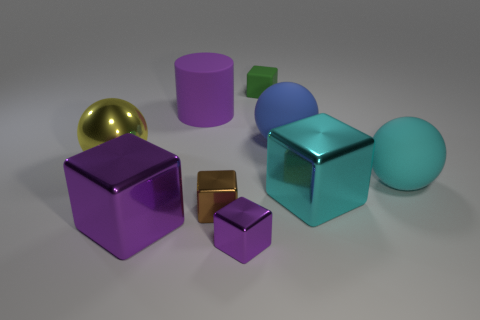Is the size of the metallic cube that is to the right of the tiny purple metal block the same as the rubber sphere in front of the blue rubber object? Upon closer examination of the image, it appears that the metallic cube to the right of the tiny purple metal block is indeed comparable in size to the rubber sphere situated in front of the blue rubber object. Both share a similar volume, suggesting that they'd occupy roughly the same amount of physical space if they were to be compared directly. 